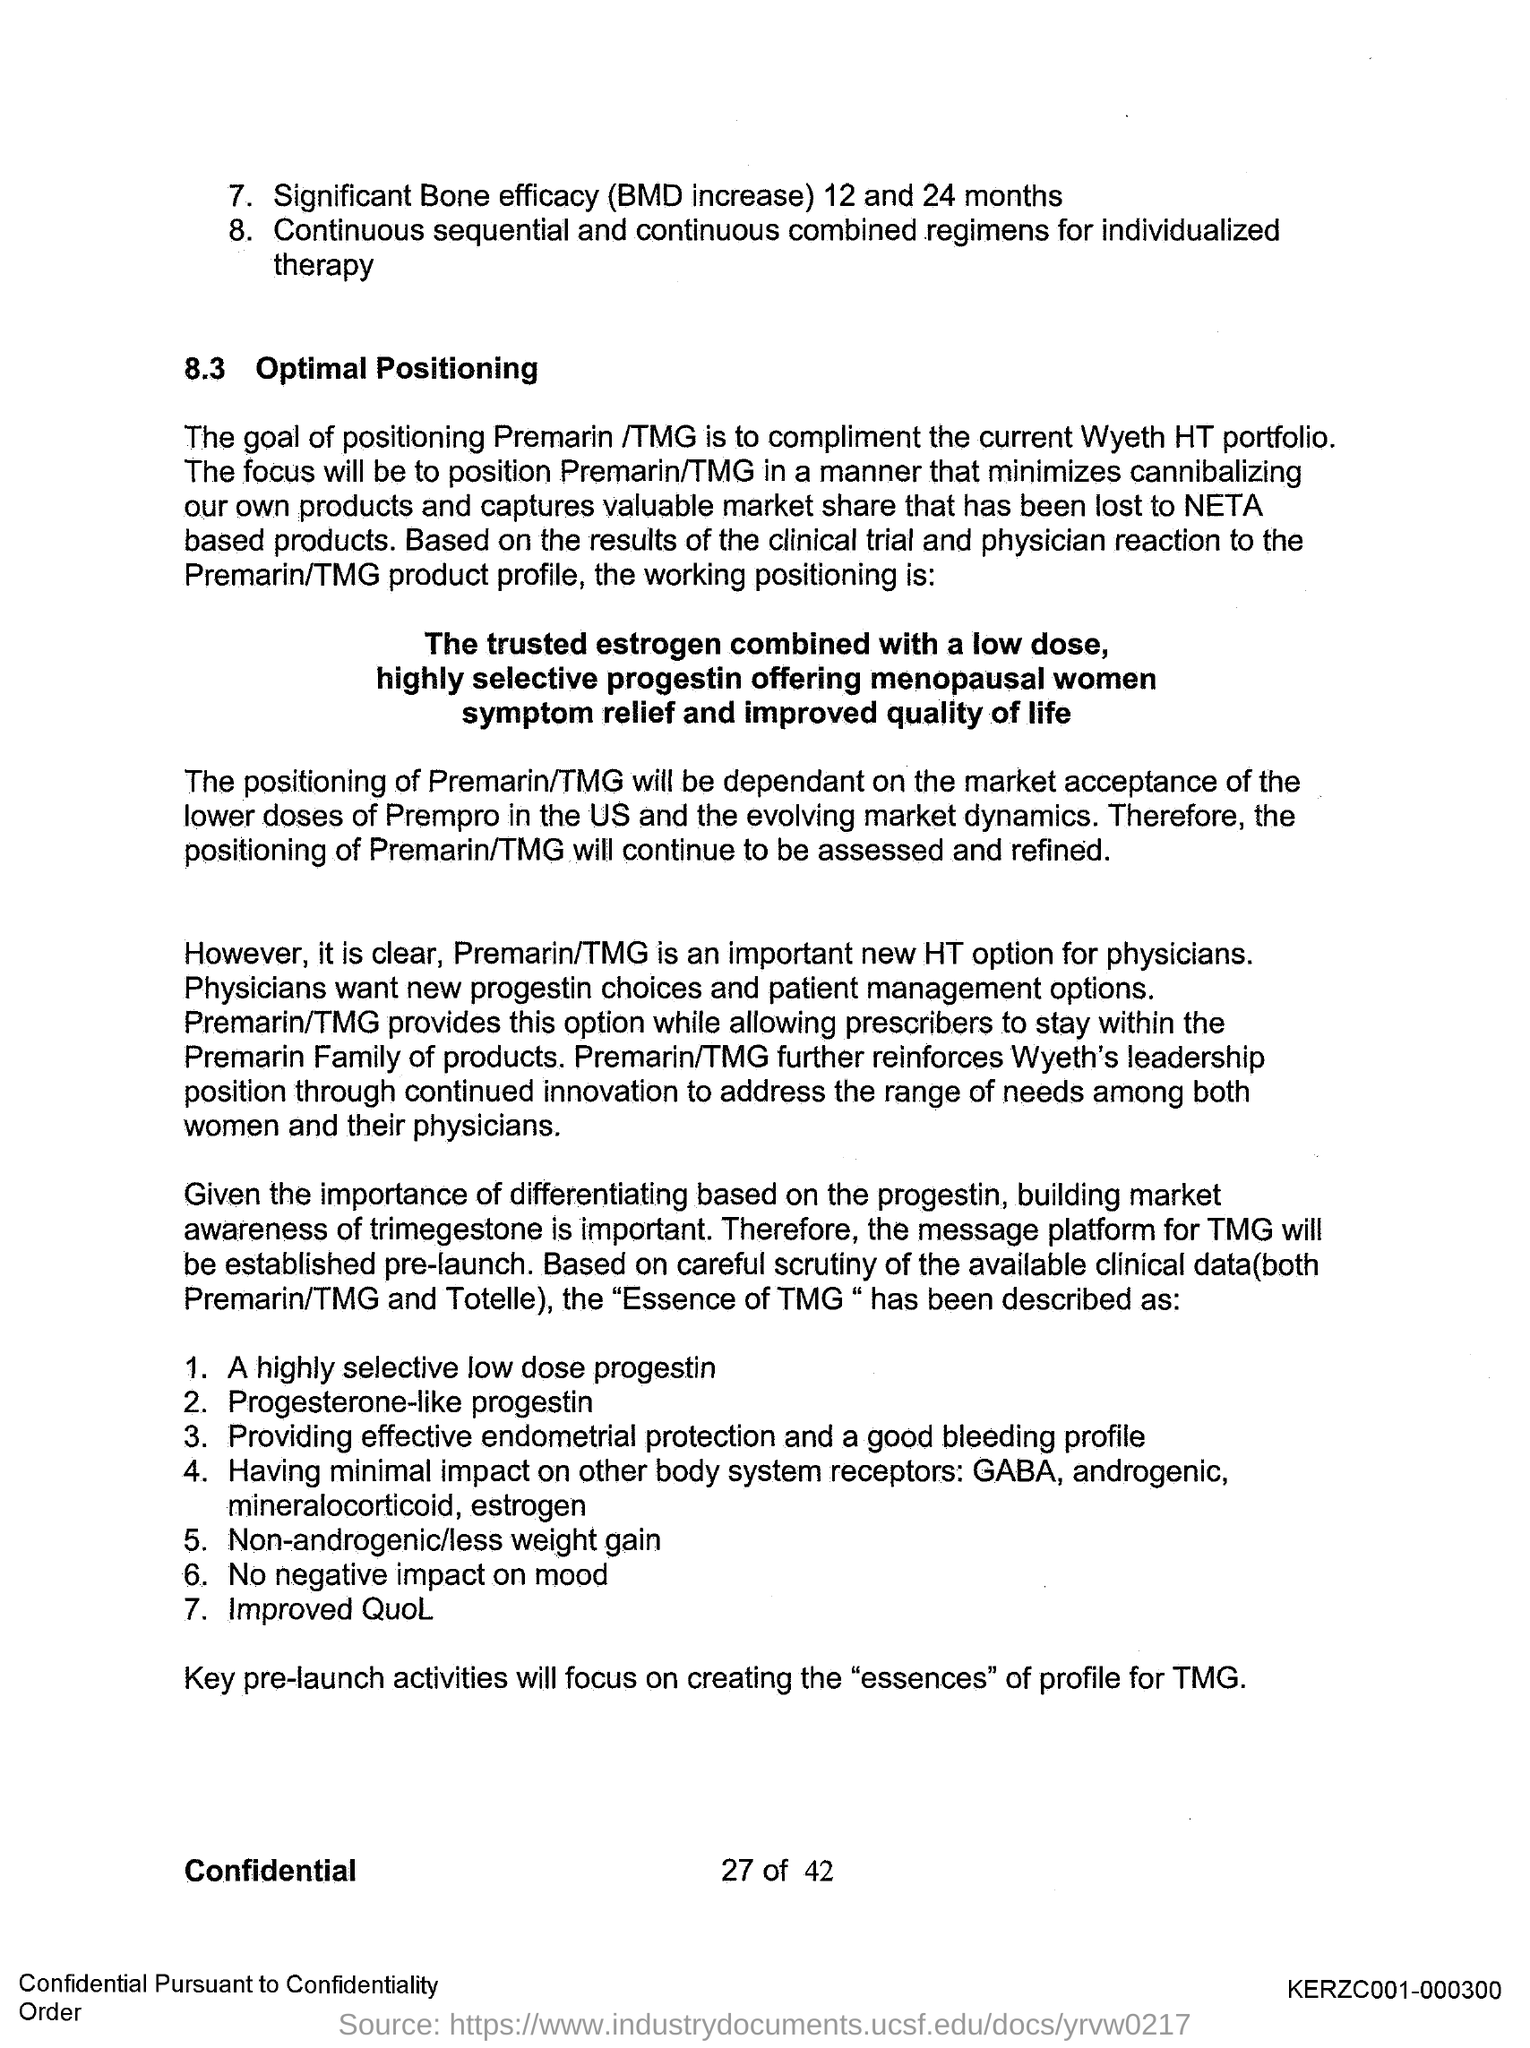What is the first title in the document?
Make the answer very short. 8.3 Optimal Positioning. 